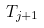<formula> <loc_0><loc_0><loc_500><loc_500>T _ { j + 1 }</formula> 